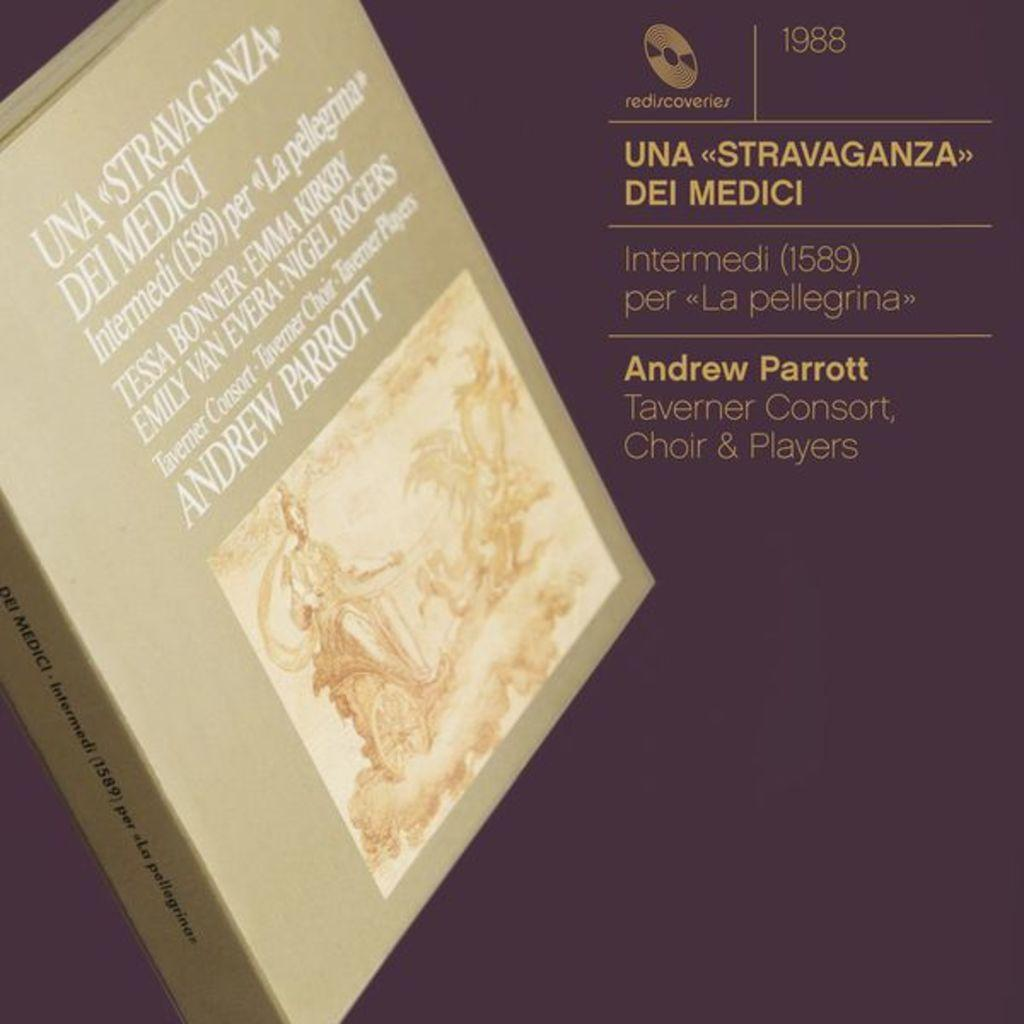<image>
Share a concise interpretation of the image provided. A 1988 recording by Andrew Parrott and the Taverner consort, choir and players.i 